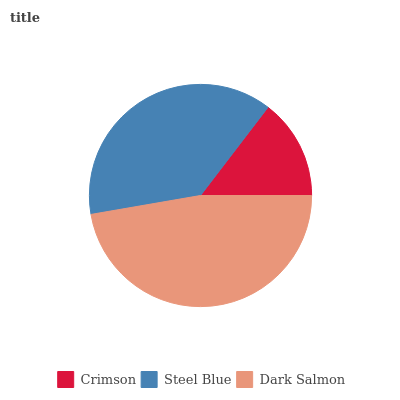Is Crimson the minimum?
Answer yes or no. Yes. Is Dark Salmon the maximum?
Answer yes or no. Yes. Is Steel Blue the minimum?
Answer yes or no. No. Is Steel Blue the maximum?
Answer yes or no. No. Is Steel Blue greater than Crimson?
Answer yes or no. Yes. Is Crimson less than Steel Blue?
Answer yes or no. Yes. Is Crimson greater than Steel Blue?
Answer yes or no. No. Is Steel Blue less than Crimson?
Answer yes or no. No. Is Steel Blue the high median?
Answer yes or no. Yes. Is Steel Blue the low median?
Answer yes or no. Yes. Is Dark Salmon the high median?
Answer yes or no. No. Is Dark Salmon the low median?
Answer yes or no. No. 